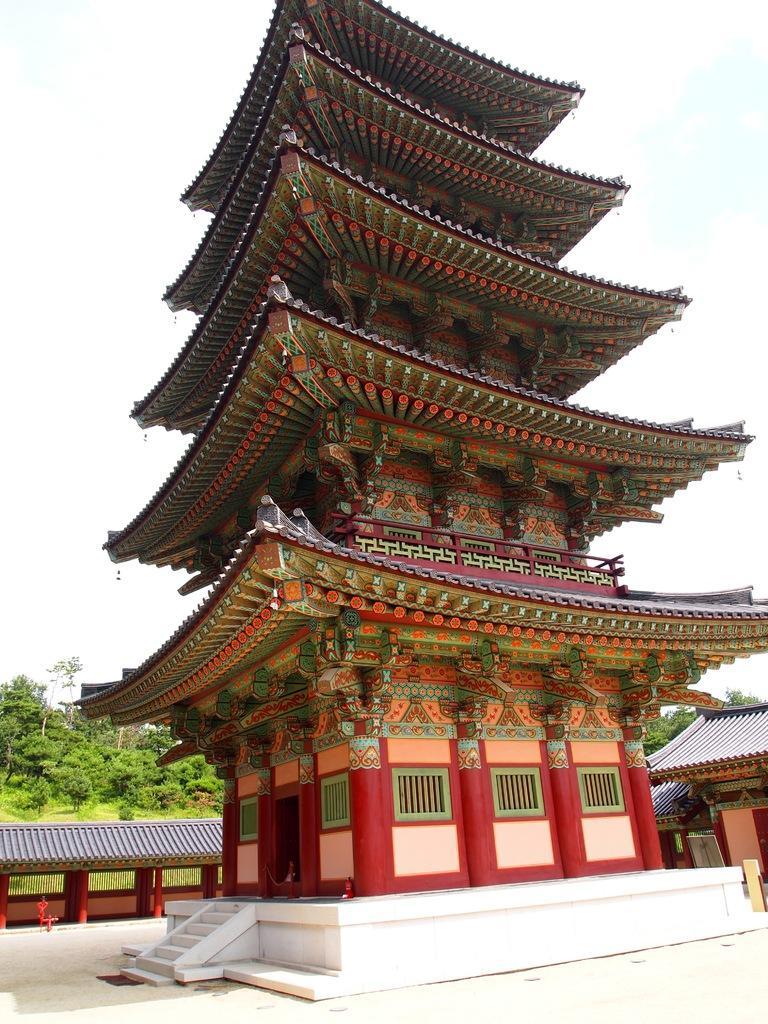In one or two sentences, can you explain what this image depicts? In this image in the center there is one house, and in the background there are some houses and trees. On the top of the image there is sky, at the bottom there is a walkway. 